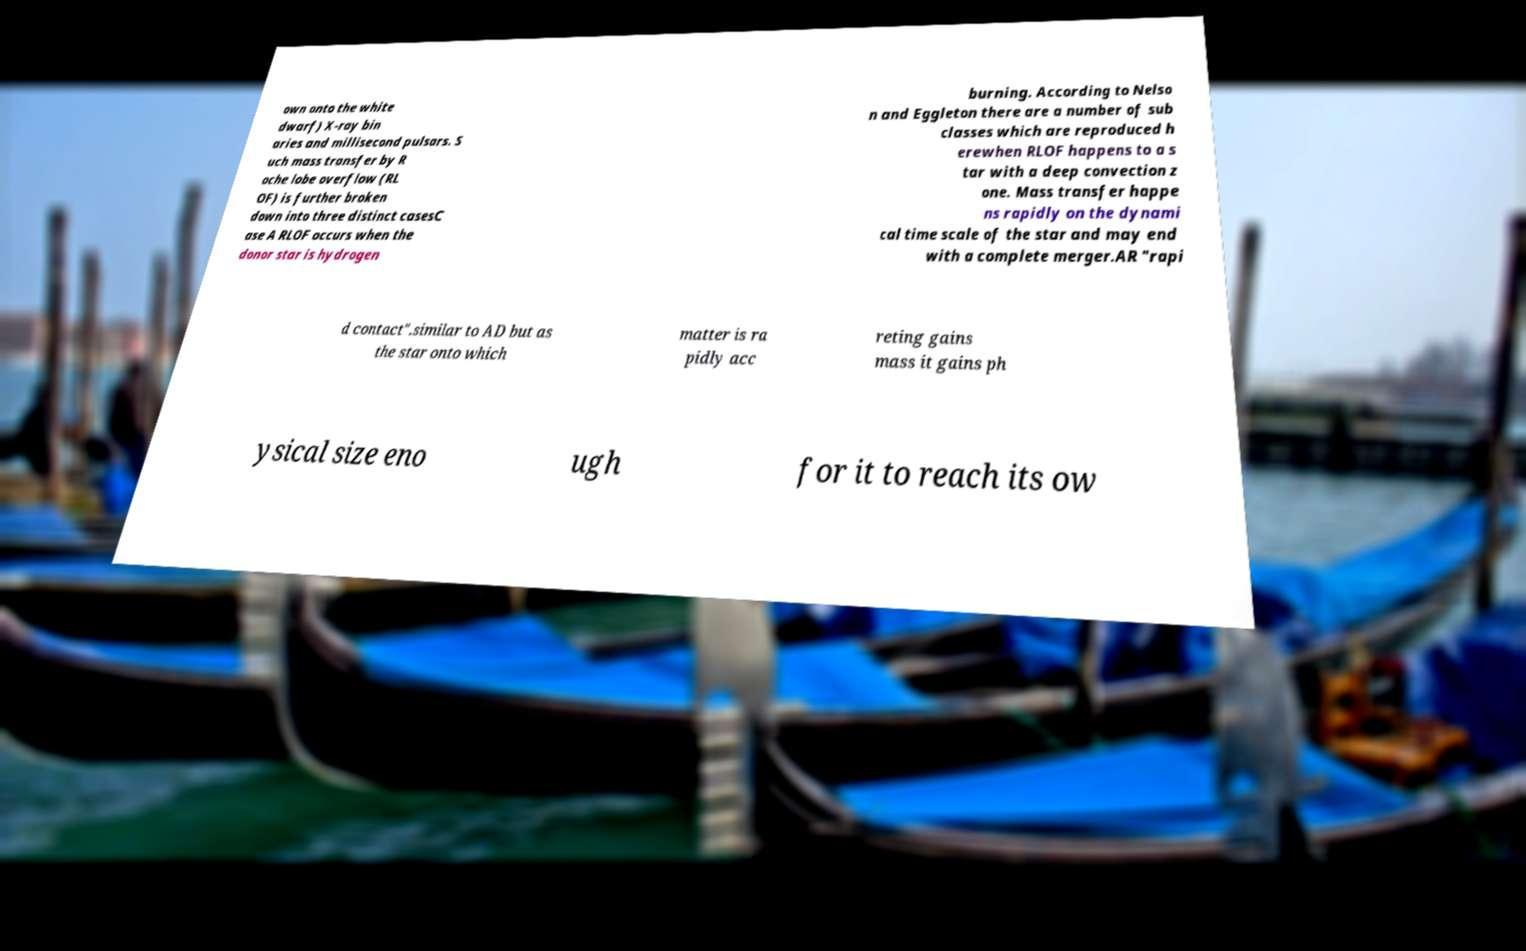Can you accurately transcribe the text from the provided image for me? own onto the white dwarf) X-ray bin aries and millisecond pulsars. S uch mass transfer by R oche lobe overflow (RL OF) is further broken down into three distinct casesC ase A RLOF occurs when the donor star is hydrogen burning. According to Nelso n and Eggleton there are a number of sub classes which are reproduced h erewhen RLOF happens to a s tar with a deep convection z one. Mass transfer happe ns rapidly on the dynami cal time scale of the star and may end with a complete merger.AR "rapi d contact".similar to AD but as the star onto which matter is ra pidly acc reting gains mass it gains ph ysical size eno ugh for it to reach its ow 